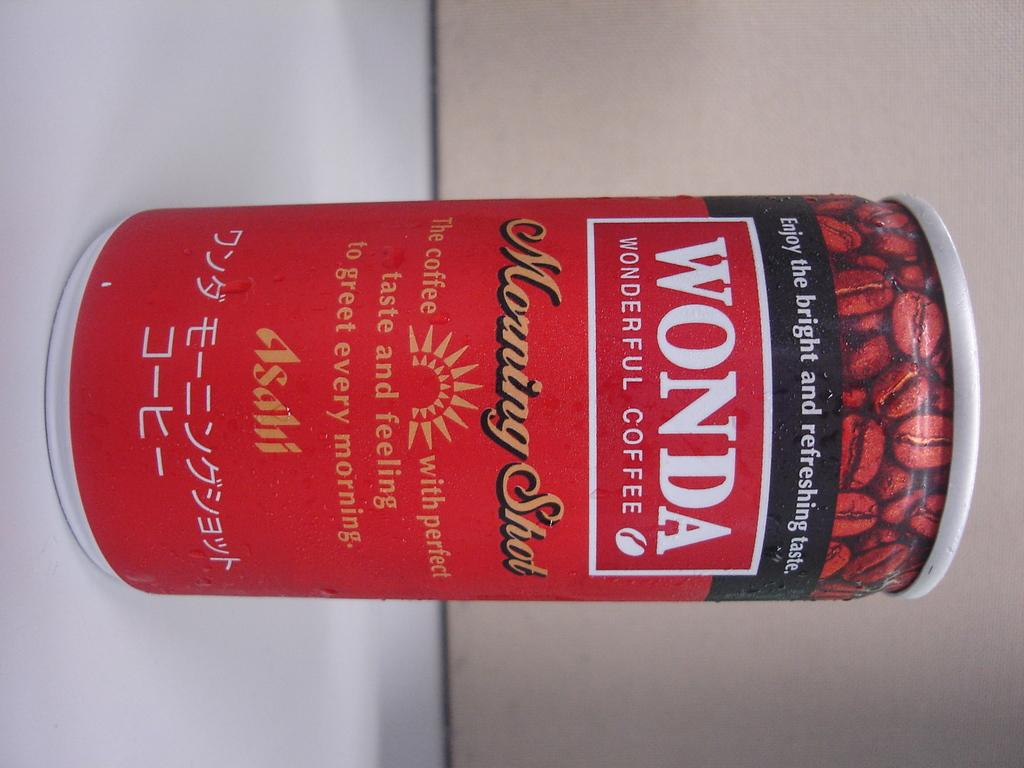<image>
Present a compact description of the photo's key features. A red can of Wonda Wonderful Coffee sits on top of a table. 